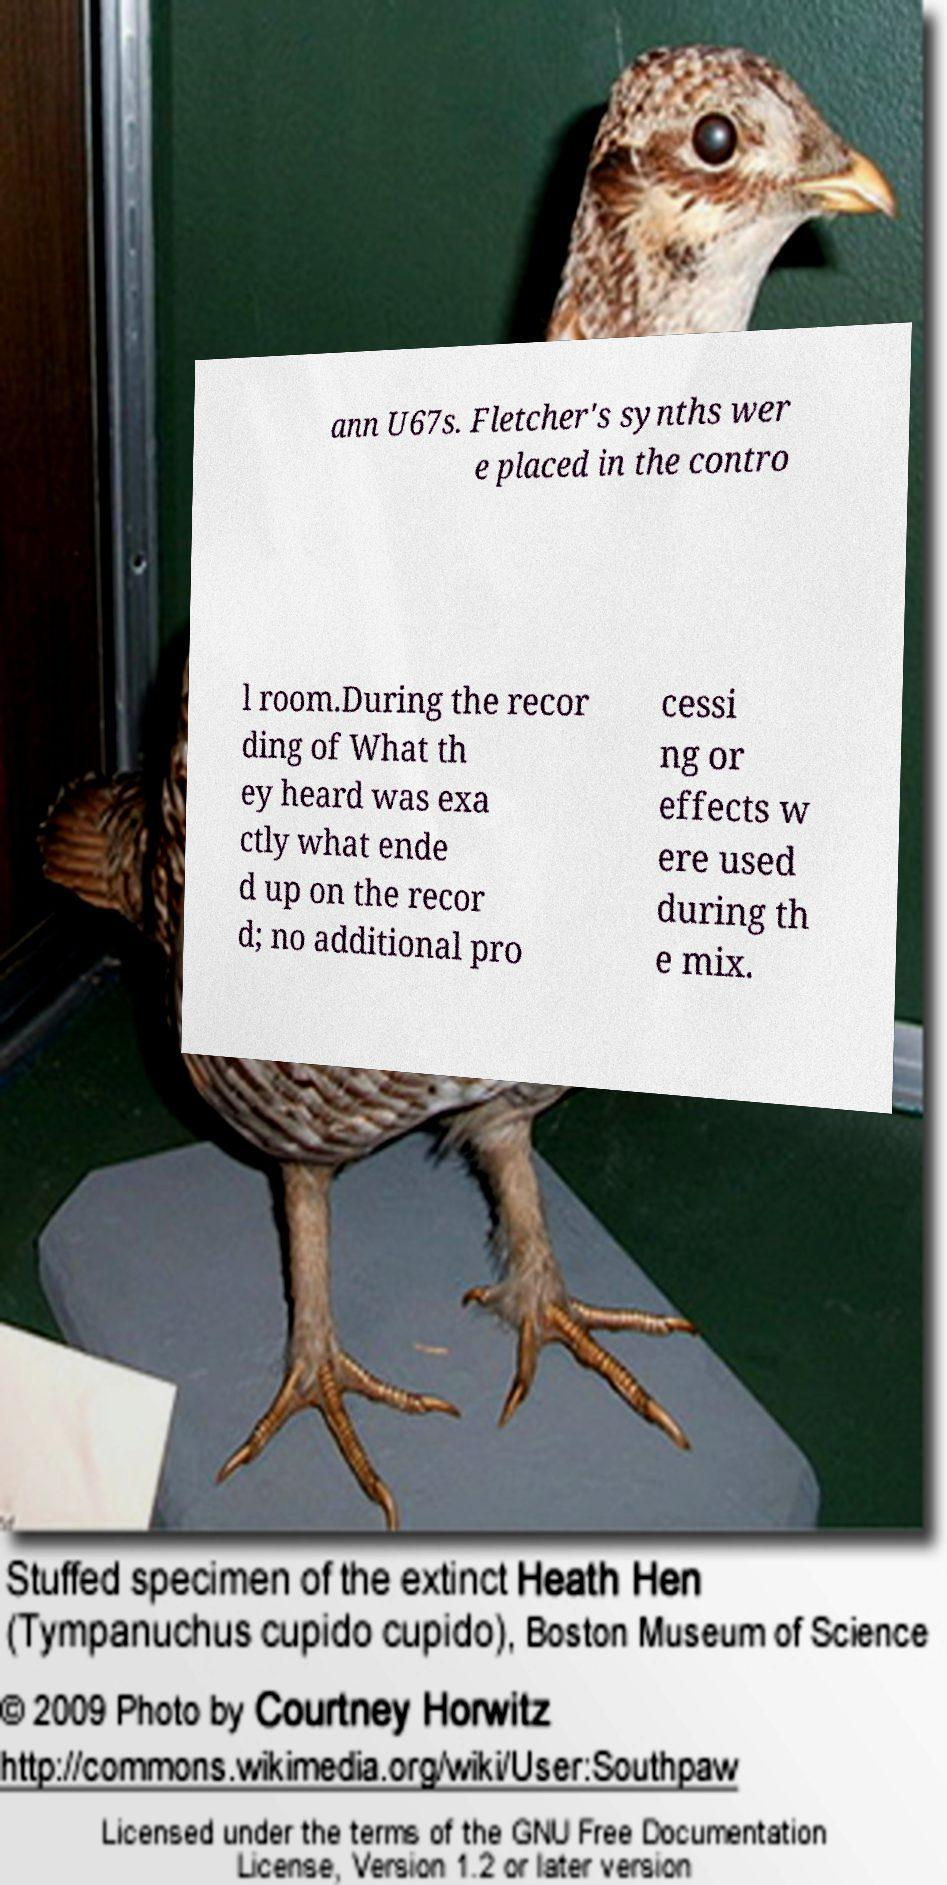Can you accurately transcribe the text from the provided image for me? ann U67s. Fletcher's synths wer e placed in the contro l room.During the recor ding of What th ey heard was exa ctly what ende d up on the recor d; no additional pro cessi ng or effects w ere used during th e mix. 